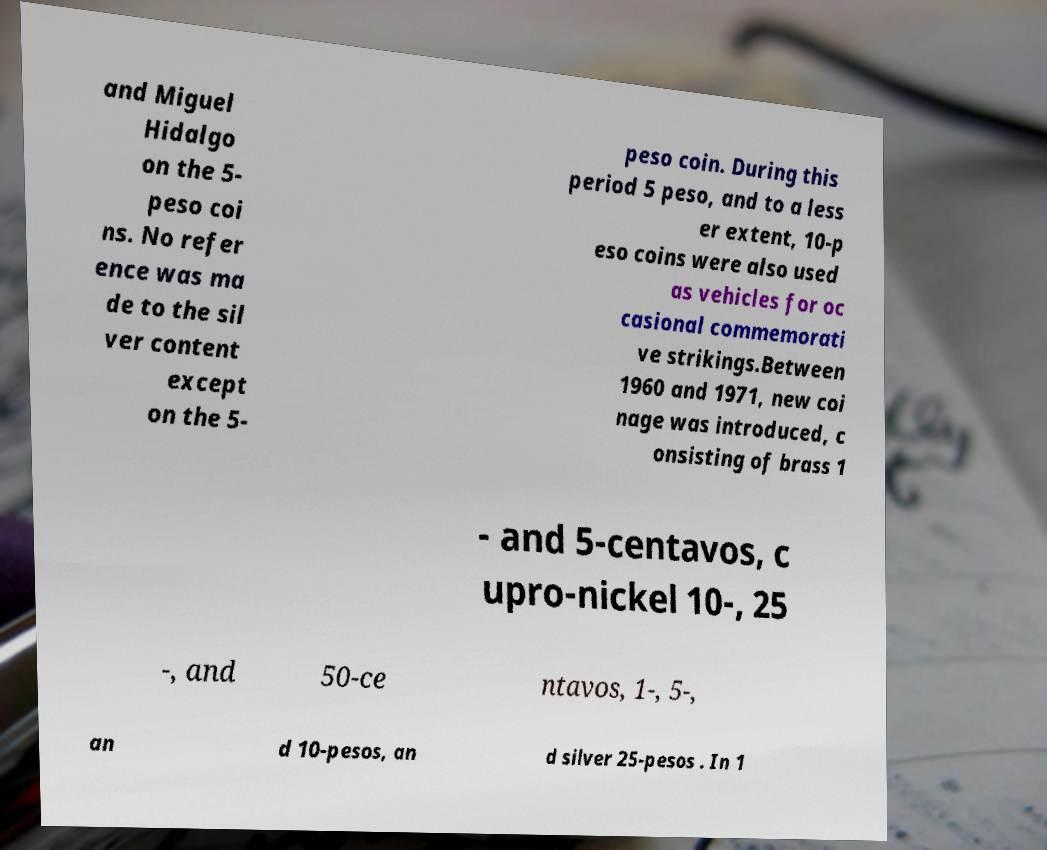Can you read and provide the text displayed in the image?This photo seems to have some interesting text. Can you extract and type it out for me? and Miguel Hidalgo on the 5- peso coi ns. No refer ence was ma de to the sil ver content except on the 5- peso coin. During this period 5 peso, and to a less er extent, 10-p eso coins were also used as vehicles for oc casional commemorati ve strikings.Between 1960 and 1971, new coi nage was introduced, c onsisting of brass 1 - and 5-centavos, c upro-nickel 10-, 25 -, and 50-ce ntavos, 1-, 5-, an d 10-pesos, an d silver 25-pesos . In 1 